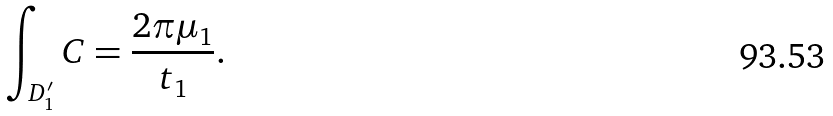Convert formula to latex. <formula><loc_0><loc_0><loc_500><loc_500>\int _ { D _ { 1 } ^ { \prime } } C = \frac { 2 \pi \mu _ { 1 } } { t _ { 1 } } .</formula> 